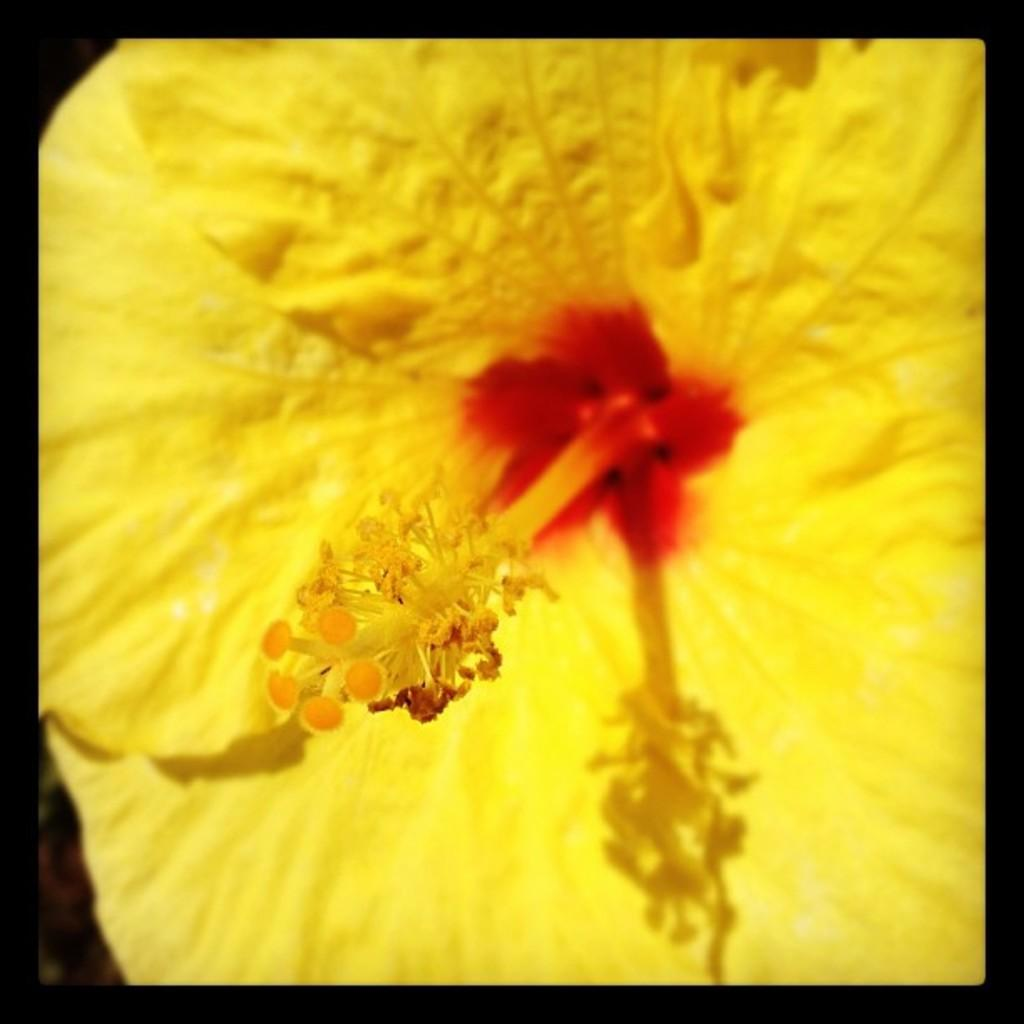What is the main subject of the image? There is a flower in the image. What can be found in the center of the flower? There are pollen grains in the center of the flower. What color are the petals of the flower? The petals of the flower are yellow. What is the color of the border around the image? There is no mention of a border color in the provided facts. Can you see a ladybug crawling on the flower in the image? There is no mention of a ladybug in the provided facts, so we cannot determine if one is present in the image. What happens when you pull the cannon in the image? There is no cannon present in the image, so we cannot answer this question. 